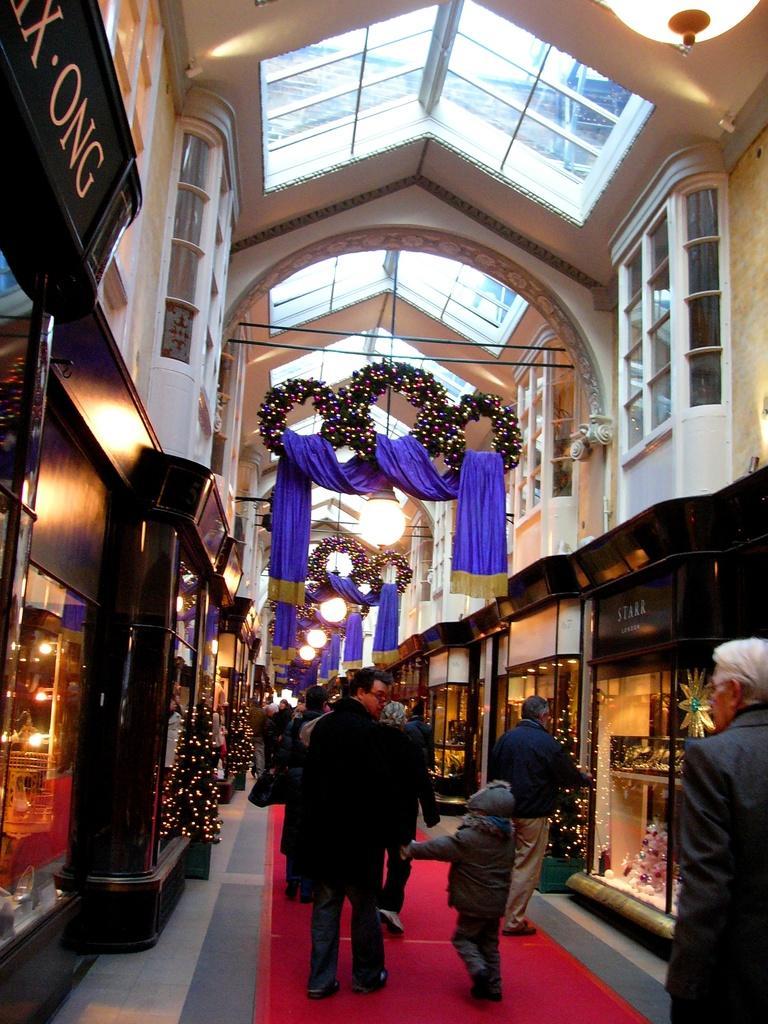In one or two sentences, can you explain what this image depicts? The Image is taken inside a building. In the center of the picture there are people, clothes, lights and ceiling. On the left there are shops and Christmas trees. On the right there are stores and Christmas trees and other objects. 